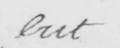Can you read and transcribe this handwriting? but 